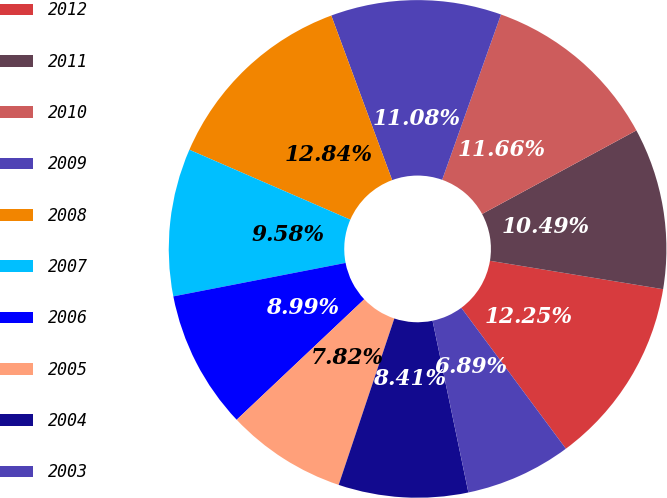<chart> <loc_0><loc_0><loc_500><loc_500><pie_chart><fcel>2012<fcel>2011<fcel>2010<fcel>2009<fcel>2008<fcel>2007<fcel>2006<fcel>2005<fcel>2004<fcel>2003<nl><fcel>12.25%<fcel>10.49%<fcel>11.66%<fcel>11.08%<fcel>12.84%<fcel>9.58%<fcel>8.99%<fcel>7.82%<fcel>8.41%<fcel>6.89%<nl></chart> 